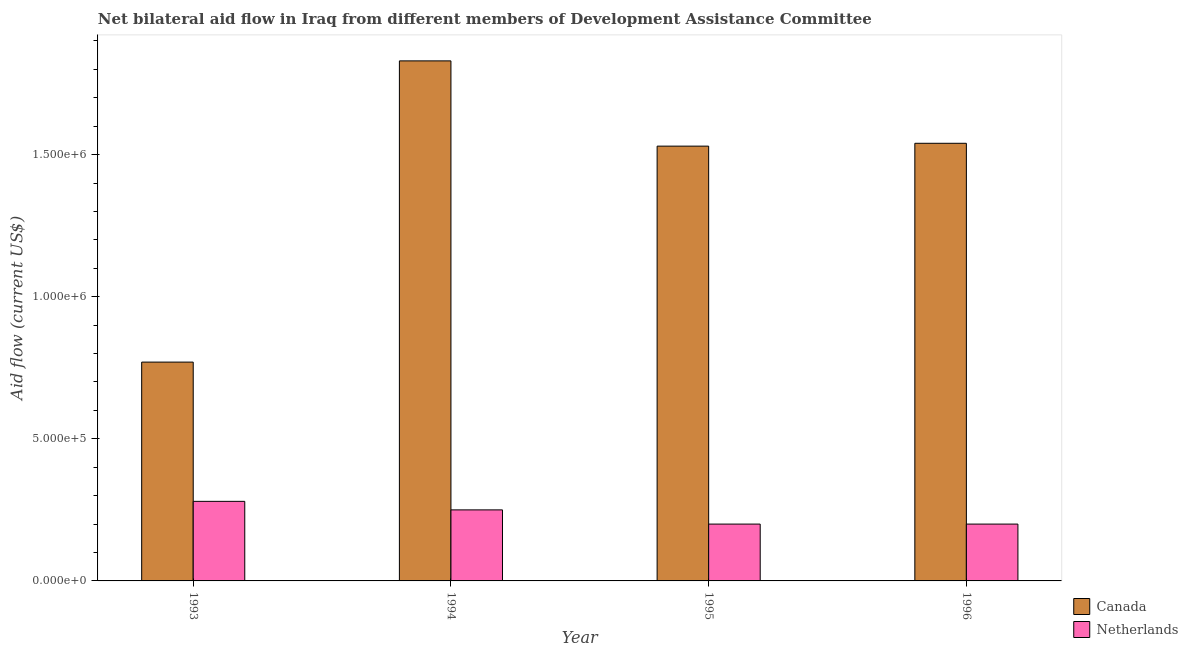How many groups of bars are there?
Give a very brief answer. 4. Are the number of bars per tick equal to the number of legend labels?
Provide a short and direct response. Yes. Are the number of bars on each tick of the X-axis equal?
Keep it short and to the point. Yes. How many bars are there on the 3rd tick from the left?
Your answer should be compact. 2. How many bars are there on the 3rd tick from the right?
Offer a terse response. 2. What is the label of the 3rd group of bars from the left?
Your answer should be very brief. 1995. In how many cases, is the number of bars for a given year not equal to the number of legend labels?
Keep it short and to the point. 0. What is the amount of aid given by canada in 1994?
Provide a succinct answer. 1.83e+06. Across all years, what is the maximum amount of aid given by netherlands?
Your answer should be very brief. 2.80e+05. Across all years, what is the minimum amount of aid given by netherlands?
Make the answer very short. 2.00e+05. In which year was the amount of aid given by canada maximum?
Provide a succinct answer. 1994. What is the total amount of aid given by netherlands in the graph?
Your answer should be very brief. 9.30e+05. What is the difference between the amount of aid given by netherlands in 1994 and that in 1996?
Give a very brief answer. 5.00e+04. What is the difference between the amount of aid given by netherlands in 1994 and the amount of aid given by canada in 1995?
Provide a succinct answer. 5.00e+04. What is the average amount of aid given by netherlands per year?
Keep it short and to the point. 2.32e+05. In how many years, is the amount of aid given by canada greater than 1700000 US$?
Provide a short and direct response. 1. What is the ratio of the amount of aid given by canada in 1993 to that in 1996?
Ensure brevity in your answer.  0.5. What is the difference between the highest and the second highest amount of aid given by netherlands?
Make the answer very short. 3.00e+04. What is the difference between the highest and the lowest amount of aid given by canada?
Provide a short and direct response. 1.06e+06. In how many years, is the amount of aid given by netherlands greater than the average amount of aid given by netherlands taken over all years?
Your answer should be compact. 2. What does the 1st bar from the left in 1996 represents?
Provide a short and direct response. Canada. How many bars are there?
Ensure brevity in your answer.  8. How many years are there in the graph?
Your answer should be very brief. 4. What is the difference between two consecutive major ticks on the Y-axis?
Give a very brief answer. 5.00e+05. How many legend labels are there?
Give a very brief answer. 2. How are the legend labels stacked?
Give a very brief answer. Vertical. What is the title of the graph?
Offer a terse response. Net bilateral aid flow in Iraq from different members of Development Assistance Committee. Does "GDP at market prices" appear as one of the legend labels in the graph?
Provide a succinct answer. No. What is the label or title of the Y-axis?
Offer a very short reply. Aid flow (current US$). What is the Aid flow (current US$) of Canada in 1993?
Offer a terse response. 7.70e+05. What is the Aid flow (current US$) of Netherlands in 1993?
Make the answer very short. 2.80e+05. What is the Aid flow (current US$) in Canada in 1994?
Make the answer very short. 1.83e+06. What is the Aid flow (current US$) of Canada in 1995?
Ensure brevity in your answer.  1.53e+06. What is the Aid flow (current US$) in Canada in 1996?
Offer a terse response. 1.54e+06. Across all years, what is the maximum Aid flow (current US$) in Canada?
Keep it short and to the point. 1.83e+06. Across all years, what is the minimum Aid flow (current US$) in Canada?
Offer a very short reply. 7.70e+05. What is the total Aid flow (current US$) of Canada in the graph?
Your response must be concise. 5.67e+06. What is the total Aid flow (current US$) in Netherlands in the graph?
Provide a succinct answer. 9.30e+05. What is the difference between the Aid flow (current US$) of Canada in 1993 and that in 1994?
Offer a very short reply. -1.06e+06. What is the difference between the Aid flow (current US$) in Canada in 1993 and that in 1995?
Provide a succinct answer. -7.60e+05. What is the difference between the Aid flow (current US$) of Canada in 1993 and that in 1996?
Offer a terse response. -7.70e+05. What is the difference between the Aid flow (current US$) of Netherlands in 1993 and that in 1996?
Your answer should be compact. 8.00e+04. What is the difference between the Aid flow (current US$) in Canada in 1994 and that in 1995?
Provide a succinct answer. 3.00e+05. What is the difference between the Aid flow (current US$) of Canada in 1993 and the Aid flow (current US$) of Netherlands in 1994?
Offer a very short reply. 5.20e+05. What is the difference between the Aid flow (current US$) in Canada in 1993 and the Aid flow (current US$) in Netherlands in 1995?
Your response must be concise. 5.70e+05. What is the difference between the Aid flow (current US$) of Canada in 1993 and the Aid flow (current US$) of Netherlands in 1996?
Your response must be concise. 5.70e+05. What is the difference between the Aid flow (current US$) of Canada in 1994 and the Aid flow (current US$) of Netherlands in 1995?
Offer a very short reply. 1.63e+06. What is the difference between the Aid flow (current US$) of Canada in 1994 and the Aid flow (current US$) of Netherlands in 1996?
Make the answer very short. 1.63e+06. What is the difference between the Aid flow (current US$) of Canada in 1995 and the Aid flow (current US$) of Netherlands in 1996?
Offer a very short reply. 1.33e+06. What is the average Aid flow (current US$) of Canada per year?
Give a very brief answer. 1.42e+06. What is the average Aid flow (current US$) of Netherlands per year?
Your response must be concise. 2.32e+05. In the year 1993, what is the difference between the Aid flow (current US$) of Canada and Aid flow (current US$) of Netherlands?
Keep it short and to the point. 4.90e+05. In the year 1994, what is the difference between the Aid flow (current US$) in Canada and Aid flow (current US$) in Netherlands?
Your response must be concise. 1.58e+06. In the year 1995, what is the difference between the Aid flow (current US$) of Canada and Aid flow (current US$) of Netherlands?
Your answer should be very brief. 1.33e+06. In the year 1996, what is the difference between the Aid flow (current US$) in Canada and Aid flow (current US$) in Netherlands?
Make the answer very short. 1.34e+06. What is the ratio of the Aid flow (current US$) of Canada in 1993 to that in 1994?
Offer a very short reply. 0.42. What is the ratio of the Aid flow (current US$) in Netherlands in 1993 to that in 1994?
Give a very brief answer. 1.12. What is the ratio of the Aid flow (current US$) in Canada in 1993 to that in 1995?
Your response must be concise. 0.5. What is the ratio of the Aid flow (current US$) of Canada in 1994 to that in 1995?
Keep it short and to the point. 1.2. What is the ratio of the Aid flow (current US$) of Netherlands in 1994 to that in 1995?
Offer a very short reply. 1.25. What is the ratio of the Aid flow (current US$) in Canada in 1994 to that in 1996?
Offer a very short reply. 1.19. What is the ratio of the Aid flow (current US$) in Netherlands in 1994 to that in 1996?
Keep it short and to the point. 1.25. What is the ratio of the Aid flow (current US$) of Netherlands in 1995 to that in 1996?
Your response must be concise. 1. What is the difference between the highest and the second highest Aid flow (current US$) in Canada?
Ensure brevity in your answer.  2.90e+05. What is the difference between the highest and the lowest Aid flow (current US$) of Canada?
Your answer should be compact. 1.06e+06. 